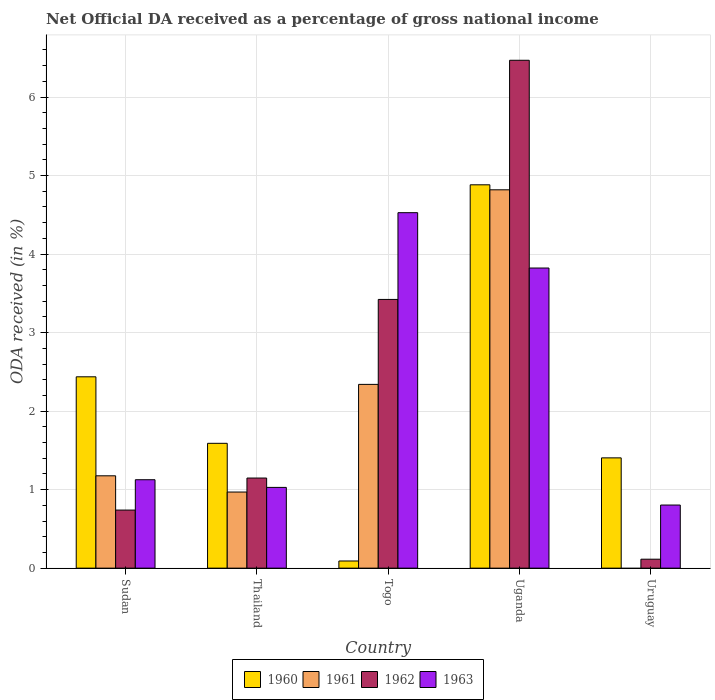How many groups of bars are there?
Offer a terse response. 5. Are the number of bars per tick equal to the number of legend labels?
Keep it short and to the point. No. Are the number of bars on each tick of the X-axis equal?
Your response must be concise. No. How many bars are there on the 4th tick from the left?
Your answer should be compact. 4. What is the label of the 1st group of bars from the left?
Keep it short and to the point. Sudan. What is the net official DA received in 1961 in Thailand?
Offer a terse response. 0.97. Across all countries, what is the maximum net official DA received in 1961?
Your response must be concise. 4.82. Across all countries, what is the minimum net official DA received in 1962?
Ensure brevity in your answer.  0.11. In which country was the net official DA received in 1961 maximum?
Provide a succinct answer. Uganda. What is the total net official DA received in 1961 in the graph?
Make the answer very short. 9.3. What is the difference between the net official DA received in 1960 in Sudan and that in Thailand?
Provide a short and direct response. 0.85. What is the difference between the net official DA received in 1962 in Sudan and the net official DA received in 1963 in Uruguay?
Ensure brevity in your answer.  -0.06. What is the average net official DA received in 1962 per country?
Your response must be concise. 2.38. What is the difference between the net official DA received of/in 1961 and net official DA received of/in 1963 in Uganda?
Make the answer very short. 1. What is the ratio of the net official DA received in 1961 in Sudan to that in Uganda?
Make the answer very short. 0.24. What is the difference between the highest and the second highest net official DA received in 1963?
Your answer should be compact. -2.7. What is the difference between the highest and the lowest net official DA received in 1960?
Give a very brief answer. 4.79. In how many countries, is the net official DA received in 1961 greater than the average net official DA received in 1961 taken over all countries?
Provide a succinct answer. 2. Is it the case that in every country, the sum of the net official DA received in 1963 and net official DA received in 1961 is greater than the sum of net official DA received in 1960 and net official DA received in 1962?
Give a very brief answer. No. Are all the bars in the graph horizontal?
Give a very brief answer. No. What is the difference between two consecutive major ticks on the Y-axis?
Make the answer very short. 1. Are the values on the major ticks of Y-axis written in scientific E-notation?
Give a very brief answer. No. Where does the legend appear in the graph?
Your response must be concise. Bottom center. What is the title of the graph?
Your answer should be compact. Net Official DA received as a percentage of gross national income. What is the label or title of the Y-axis?
Ensure brevity in your answer.  ODA received (in %). What is the ODA received (in %) in 1960 in Sudan?
Keep it short and to the point. 2.44. What is the ODA received (in %) of 1961 in Sudan?
Your answer should be very brief. 1.18. What is the ODA received (in %) of 1962 in Sudan?
Offer a terse response. 0.74. What is the ODA received (in %) of 1963 in Sudan?
Provide a short and direct response. 1.13. What is the ODA received (in %) in 1960 in Thailand?
Ensure brevity in your answer.  1.59. What is the ODA received (in %) of 1961 in Thailand?
Offer a very short reply. 0.97. What is the ODA received (in %) in 1962 in Thailand?
Make the answer very short. 1.15. What is the ODA received (in %) of 1963 in Thailand?
Your answer should be compact. 1.03. What is the ODA received (in %) of 1960 in Togo?
Your response must be concise. 0.09. What is the ODA received (in %) in 1961 in Togo?
Keep it short and to the point. 2.34. What is the ODA received (in %) in 1962 in Togo?
Your answer should be very brief. 3.42. What is the ODA received (in %) in 1963 in Togo?
Ensure brevity in your answer.  4.53. What is the ODA received (in %) in 1960 in Uganda?
Keep it short and to the point. 4.88. What is the ODA received (in %) of 1961 in Uganda?
Offer a terse response. 4.82. What is the ODA received (in %) in 1962 in Uganda?
Offer a very short reply. 6.47. What is the ODA received (in %) in 1963 in Uganda?
Your answer should be compact. 3.82. What is the ODA received (in %) in 1960 in Uruguay?
Make the answer very short. 1.4. What is the ODA received (in %) in 1962 in Uruguay?
Give a very brief answer. 0.11. What is the ODA received (in %) of 1963 in Uruguay?
Your answer should be compact. 0.8. Across all countries, what is the maximum ODA received (in %) in 1960?
Keep it short and to the point. 4.88. Across all countries, what is the maximum ODA received (in %) of 1961?
Provide a short and direct response. 4.82. Across all countries, what is the maximum ODA received (in %) in 1962?
Provide a succinct answer. 6.47. Across all countries, what is the maximum ODA received (in %) of 1963?
Provide a short and direct response. 4.53. Across all countries, what is the minimum ODA received (in %) in 1960?
Make the answer very short. 0.09. Across all countries, what is the minimum ODA received (in %) in 1961?
Make the answer very short. 0. Across all countries, what is the minimum ODA received (in %) in 1962?
Provide a short and direct response. 0.11. Across all countries, what is the minimum ODA received (in %) of 1963?
Make the answer very short. 0.8. What is the total ODA received (in %) of 1960 in the graph?
Your answer should be compact. 10.41. What is the total ODA received (in %) in 1961 in the graph?
Provide a succinct answer. 9.3. What is the total ODA received (in %) of 1962 in the graph?
Your answer should be compact. 11.89. What is the total ODA received (in %) of 1963 in the graph?
Offer a very short reply. 11.31. What is the difference between the ODA received (in %) in 1960 in Sudan and that in Thailand?
Give a very brief answer. 0.85. What is the difference between the ODA received (in %) of 1961 in Sudan and that in Thailand?
Give a very brief answer. 0.21. What is the difference between the ODA received (in %) in 1962 in Sudan and that in Thailand?
Ensure brevity in your answer.  -0.41. What is the difference between the ODA received (in %) of 1963 in Sudan and that in Thailand?
Your answer should be very brief. 0.1. What is the difference between the ODA received (in %) in 1960 in Sudan and that in Togo?
Your response must be concise. 2.35. What is the difference between the ODA received (in %) in 1961 in Sudan and that in Togo?
Your answer should be compact. -1.16. What is the difference between the ODA received (in %) of 1962 in Sudan and that in Togo?
Give a very brief answer. -2.68. What is the difference between the ODA received (in %) of 1963 in Sudan and that in Togo?
Provide a short and direct response. -3.4. What is the difference between the ODA received (in %) of 1960 in Sudan and that in Uganda?
Offer a terse response. -2.45. What is the difference between the ODA received (in %) in 1961 in Sudan and that in Uganda?
Your answer should be very brief. -3.64. What is the difference between the ODA received (in %) in 1962 in Sudan and that in Uganda?
Your response must be concise. -5.73. What is the difference between the ODA received (in %) in 1963 in Sudan and that in Uganda?
Provide a succinct answer. -2.7. What is the difference between the ODA received (in %) of 1960 in Sudan and that in Uruguay?
Keep it short and to the point. 1.03. What is the difference between the ODA received (in %) of 1962 in Sudan and that in Uruguay?
Provide a succinct answer. 0.63. What is the difference between the ODA received (in %) of 1963 in Sudan and that in Uruguay?
Offer a terse response. 0.32. What is the difference between the ODA received (in %) in 1960 in Thailand and that in Togo?
Make the answer very short. 1.5. What is the difference between the ODA received (in %) of 1961 in Thailand and that in Togo?
Your response must be concise. -1.37. What is the difference between the ODA received (in %) of 1962 in Thailand and that in Togo?
Your answer should be very brief. -2.27. What is the difference between the ODA received (in %) in 1963 in Thailand and that in Togo?
Give a very brief answer. -3.5. What is the difference between the ODA received (in %) of 1960 in Thailand and that in Uganda?
Keep it short and to the point. -3.29. What is the difference between the ODA received (in %) in 1961 in Thailand and that in Uganda?
Your answer should be compact. -3.85. What is the difference between the ODA received (in %) of 1962 in Thailand and that in Uganda?
Give a very brief answer. -5.32. What is the difference between the ODA received (in %) of 1963 in Thailand and that in Uganda?
Keep it short and to the point. -2.79. What is the difference between the ODA received (in %) in 1960 in Thailand and that in Uruguay?
Keep it short and to the point. 0.19. What is the difference between the ODA received (in %) in 1962 in Thailand and that in Uruguay?
Provide a short and direct response. 1.03. What is the difference between the ODA received (in %) of 1963 in Thailand and that in Uruguay?
Your answer should be very brief. 0.22. What is the difference between the ODA received (in %) of 1960 in Togo and that in Uganda?
Your answer should be very brief. -4.79. What is the difference between the ODA received (in %) in 1961 in Togo and that in Uganda?
Give a very brief answer. -2.48. What is the difference between the ODA received (in %) of 1962 in Togo and that in Uganda?
Provide a short and direct response. -3.05. What is the difference between the ODA received (in %) of 1963 in Togo and that in Uganda?
Your answer should be very brief. 0.7. What is the difference between the ODA received (in %) in 1960 in Togo and that in Uruguay?
Ensure brevity in your answer.  -1.31. What is the difference between the ODA received (in %) of 1962 in Togo and that in Uruguay?
Give a very brief answer. 3.31. What is the difference between the ODA received (in %) in 1963 in Togo and that in Uruguay?
Your answer should be very brief. 3.72. What is the difference between the ODA received (in %) of 1960 in Uganda and that in Uruguay?
Offer a terse response. 3.48. What is the difference between the ODA received (in %) of 1962 in Uganda and that in Uruguay?
Your answer should be very brief. 6.35. What is the difference between the ODA received (in %) of 1963 in Uganda and that in Uruguay?
Your answer should be compact. 3.02. What is the difference between the ODA received (in %) in 1960 in Sudan and the ODA received (in %) in 1961 in Thailand?
Provide a short and direct response. 1.47. What is the difference between the ODA received (in %) in 1960 in Sudan and the ODA received (in %) in 1962 in Thailand?
Your answer should be very brief. 1.29. What is the difference between the ODA received (in %) of 1960 in Sudan and the ODA received (in %) of 1963 in Thailand?
Provide a succinct answer. 1.41. What is the difference between the ODA received (in %) in 1961 in Sudan and the ODA received (in %) in 1962 in Thailand?
Make the answer very short. 0.03. What is the difference between the ODA received (in %) of 1961 in Sudan and the ODA received (in %) of 1963 in Thailand?
Give a very brief answer. 0.15. What is the difference between the ODA received (in %) of 1962 in Sudan and the ODA received (in %) of 1963 in Thailand?
Provide a short and direct response. -0.29. What is the difference between the ODA received (in %) in 1960 in Sudan and the ODA received (in %) in 1961 in Togo?
Your response must be concise. 0.1. What is the difference between the ODA received (in %) of 1960 in Sudan and the ODA received (in %) of 1962 in Togo?
Make the answer very short. -0.99. What is the difference between the ODA received (in %) in 1960 in Sudan and the ODA received (in %) in 1963 in Togo?
Provide a succinct answer. -2.09. What is the difference between the ODA received (in %) in 1961 in Sudan and the ODA received (in %) in 1962 in Togo?
Your answer should be very brief. -2.25. What is the difference between the ODA received (in %) of 1961 in Sudan and the ODA received (in %) of 1963 in Togo?
Provide a succinct answer. -3.35. What is the difference between the ODA received (in %) of 1962 in Sudan and the ODA received (in %) of 1963 in Togo?
Offer a terse response. -3.79. What is the difference between the ODA received (in %) in 1960 in Sudan and the ODA received (in %) in 1961 in Uganda?
Offer a very short reply. -2.38. What is the difference between the ODA received (in %) in 1960 in Sudan and the ODA received (in %) in 1962 in Uganda?
Your answer should be very brief. -4.03. What is the difference between the ODA received (in %) of 1960 in Sudan and the ODA received (in %) of 1963 in Uganda?
Ensure brevity in your answer.  -1.39. What is the difference between the ODA received (in %) in 1961 in Sudan and the ODA received (in %) in 1962 in Uganda?
Offer a very short reply. -5.29. What is the difference between the ODA received (in %) of 1961 in Sudan and the ODA received (in %) of 1963 in Uganda?
Provide a short and direct response. -2.65. What is the difference between the ODA received (in %) in 1962 in Sudan and the ODA received (in %) in 1963 in Uganda?
Offer a very short reply. -3.08. What is the difference between the ODA received (in %) in 1960 in Sudan and the ODA received (in %) in 1962 in Uruguay?
Keep it short and to the point. 2.32. What is the difference between the ODA received (in %) of 1960 in Sudan and the ODA received (in %) of 1963 in Uruguay?
Offer a very short reply. 1.63. What is the difference between the ODA received (in %) in 1961 in Sudan and the ODA received (in %) in 1962 in Uruguay?
Ensure brevity in your answer.  1.06. What is the difference between the ODA received (in %) in 1961 in Sudan and the ODA received (in %) in 1963 in Uruguay?
Make the answer very short. 0.37. What is the difference between the ODA received (in %) in 1962 in Sudan and the ODA received (in %) in 1963 in Uruguay?
Offer a very short reply. -0.06. What is the difference between the ODA received (in %) in 1960 in Thailand and the ODA received (in %) in 1961 in Togo?
Provide a succinct answer. -0.75. What is the difference between the ODA received (in %) of 1960 in Thailand and the ODA received (in %) of 1962 in Togo?
Provide a short and direct response. -1.83. What is the difference between the ODA received (in %) in 1960 in Thailand and the ODA received (in %) in 1963 in Togo?
Give a very brief answer. -2.94. What is the difference between the ODA received (in %) in 1961 in Thailand and the ODA received (in %) in 1962 in Togo?
Offer a very short reply. -2.45. What is the difference between the ODA received (in %) in 1961 in Thailand and the ODA received (in %) in 1963 in Togo?
Make the answer very short. -3.56. What is the difference between the ODA received (in %) of 1962 in Thailand and the ODA received (in %) of 1963 in Togo?
Give a very brief answer. -3.38. What is the difference between the ODA received (in %) in 1960 in Thailand and the ODA received (in %) in 1961 in Uganda?
Your answer should be very brief. -3.23. What is the difference between the ODA received (in %) of 1960 in Thailand and the ODA received (in %) of 1962 in Uganda?
Your response must be concise. -4.88. What is the difference between the ODA received (in %) of 1960 in Thailand and the ODA received (in %) of 1963 in Uganda?
Your answer should be very brief. -2.23. What is the difference between the ODA received (in %) of 1961 in Thailand and the ODA received (in %) of 1962 in Uganda?
Your response must be concise. -5.5. What is the difference between the ODA received (in %) of 1961 in Thailand and the ODA received (in %) of 1963 in Uganda?
Keep it short and to the point. -2.85. What is the difference between the ODA received (in %) of 1962 in Thailand and the ODA received (in %) of 1963 in Uganda?
Your answer should be very brief. -2.67. What is the difference between the ODA received (in %) of 1960 in Thailand and the ODA received (in %) of 1962 in Uruguay?
Provide a short and direct response. 1.48. What is the difference between the ODA received (in %) in 1960 in Thailand and the ODA received (in %) in 1963 in Uruguay?
Keep it short and to the point. 0.79. What is the difference between the ODA received (in %) in 1961 in Thailand and the ODA received (in %) in 1962 in Uruguay?
Provide a short and direct response. 0.86. What is the difference between the ODA received (in %) of 1961 in Thailand and the ODA received (in %) of 1963 in Uruguay?
Your answer should be very brief. 0.17. What is the difference between the ODA received (in %) of 1962 in Thailand and the ODA received (in %) of 1963 in Uruguay?
Give a very brief answer. 0.34. What is the difference between the ODA received (in %) in 1960 in Togo and the ODA received (in %) in 1961 in Uganda?
Your response must be concise. -4.73. What is the difference between the ODA received (in %) in 1960 in Togo and the ODA received (in %) in 1962 in Uganda?
Give a very brief answer. -6.38. What is the difference between the ODA received (in %) of 1960 in Togo and the ODA received (in %) of 1963 in Uganda?
Offer a terse response. -3.73. What is the difference between the ODA received (in %) in 1961 in Togo and the ODA received (in %) in 1962 in Uganda?
Offer a terse response. -4.13. What is the difference between the ODA received (in %) in 1961 in Togo and the ODA received (in %) in 1963 in Uganda?
Your response must be concise. -1.48. What is the difference between the ODA received (in %) in 1962 in Togo and the ODA received (in %) in 1963 in Uganda?
Your answer should be compact. -0.4. What is the difference between the ODA received (in %) of 1960 in Togo and the ODA received (in %) of 1962 in Uruguay?
Offer a terse response. -0.02. What is the difference between the ODA received (in %) in 1960 in Togo and the ODA received (in %) in 1963 in Uruguay?
Provide a short and direct response. -0.71. What is the difference between the ODA received (in %) of 1961 in Togo and the ODA received (in %) of 1962 in Uruguay?
Keep it short and to the point. 2.23. What is the difference between the ODA received (in %) of 1961 in Togo and the ODA received (in %) of 1963 in Uruguay?
Ensure brevity in your answer.  1.54. What is the difference between the ODA received (in %) of 1962 in Togo and the ODA received (in %) of 1963 in Uruguay?
Your response must be concise. 2.62. What is the difference between the ODA received (in %) of 1960 in Uganda and the ODA received (in %) of 1962 in Uruguay?
Give a very brief answer. 4.77. What is the difference between the ODA received (in %) of 1960 in Uganda and the ODA received (in %) of 1963 in Uruguay?
Your answer should be compact. 4.08. What is the difference between the ODA received (in %) of 1961 in Uganda and the ODA received (in %) of 1962 in Uruguay?
Make the answer very short. 4.7. What is the difference between the ODA received (in %) in 1961 in Uganda and the ODA received (in %) in 1963 in Uruguay?
Provide a short and direct response. 4.01. What is the difference between the ODA received (in %) of 1962 in Uganda and the ODA received (in %) of 1963 in Uruguay?
Give a very brief answer. 5.66. What is the average ODA received (in %) of 1960 per country?
Ensure brevity in your answer.  2.08. What is the average ODA received (in %) in 1961 per country?
Your answer should be very brief. 1.86. What is the average ODA received (in %) in 1962 per country?
Make the answer very short. 2.38. What is the average ODA received (in %) in 1963 per country?
Provide a short and direct response. 2.26. What is the difference between the ODA received (in %) in 1960 and ODA received (in %) in 1961 in Sudan?
Your answer should be compact. 1.26. What is the difference between the ODA received (in %) in 1960 and ODA received (in %) in 1962 in Sudan?
Ensure brevity in your answer.  1.7. What is the difference between the ODA received (in %) of 1960 and ODA received (in %) of 1963 in Sudan?
Your answer should be compact. 1.31. What is the difference between the ODA received (in %) of 1961 and ODA received (in %) of 1962 in Sudan?
Your answer should be compact. 0.44. What is the difference between the ODA received (in %) in 1961 and ODA received (in %) in 1963 in Sudan?
Make the answer very short. 0.05. What is the difference between the ODA received (in %) in 1962 and ODA received (in %) in 1963 in Sudan?
Keep it short and to the point. -0.39. What is the difference between the ODA received (in %) of 1960 and ODA received (in %) of 1961 in Thailand?
Give a very brief answer. 0.62. What is the difference between the ODA received (in %) in 1960 and ODA received (in %) in 1962 in Thailand?
Ensure brevity in your answer.  0.44. What is the difference between the ODA received (in %) in 1960 and ODA received (in %) in 1963 in Thailand?
Your answer should be compact. 0.56. What is the difference between the ODA received (in %) of 1961 and ODA received (in %) of 1962 in Thailand?
Your answer should be compact. -0.18. What is the difference between the ODA received (in %) of 1961 and ODA received (in %) of 1963 in Thailand?
Ensure brevity in your answer.  -0.06. What is the difference between the ODA received (in %) in 1962 and ODA received (in %) in 1963 in Thailand?
Your answer should be very brief. 0.12. What is the difference between the ODA received (in %) in 1960 and ODA received (in %) in 1961 in Togo?
Provide a short and direct response. -2.25. What is the difference between the ODA received (in %) of 1960 and ODA received (in %) of 1962 in Togo?
Give a very brief answer. -3.33. What is the difference between the ODA received (in %) in 1960 and ODA received (in %) in 1963 in Togo?
Your response must be concise. -4.44. What is the difference between the ODA received (in %) of 1961 and ODA received (in %) of 1962 in Togo?
Ensure brevity in your answer.  -1.08. What is the difference between the ODA received (in %) of 1961 and ODA received (in %) of 1963 in Togo?
Your answer should be compact. -2.19. What is the difference between the ODA received (in %) of 1962 and ODA received (in %) of 1963 in Togo?
Keep it short and to the point. -1.1. What is the difference between the ODA received (in %) of 1960 and ODA received (in %) of 1961 in Uganda?
Your answer should be compact. 0.06. What is the difference between the ODA received (in %) of 1960 and ODA received (in %) of 1962 in Uganda?
Offer a very short reply. -1.59. What is the difference between the ODA received (in %) in 1960 and ODA received (in %) in 1963 in Uganda?
Offer a very short reply. 1.06. What is the difference between the ODA received (in %) of 1961 and ODA received (in %) of 1962 in Uganda?
Your answer should be compact. -1.65. What is the difference between the ODA received (in %) of 1962 and ODA received (in %) of 1963 in Uganda?
Keep it short and to the point. 2.65. What is the difference between the ODA received (in %) in 1960 and ODA received (in %) in 1962 in Uruguay?
Keep it short and to the point. 1.29. What is the difference between the ODA received (in %) of 1960 and ODA received (in %) of 1963 in Uruguay?
Provide a short and direct response. 0.6. What is the difference between the ODA received (in %) of 1962 and ODA received (in %) of 1963 in Uruguay?
Offer a terse response. -0.69. What is the ratio of the ODA received (in %) of 1960 in Sudan to that in Thailand?
Give a very brief answer. 1.53. What is the ratio of the ODA received (in %) of 1961 in Sudan to that in Thailand?
Provide a short and direct response. 1.21. What is the ratio of the ODA received (in %) of 1962 in Sudan to that in Thailand?
Your answer should be compact. 0.64. What is the ratio of the ODA received (in %) in 1963 in Sudan to that in Thailand?
Ensure brevity in your answer.  1.1. What is the ratio of the ODA received (in %) of 1960 in Sudan to that in Togo?
Ensure brevity in your answer.  26.73. What is the ratio of the ODA received (in %) in 1961 in Sudan to that in Togo?
Offer a very short reply. 0.5. What is the ratio of the ODA received (in %) in 1962 in Sudan to that in Togo?
Your response must be concise. 0.22. What is the ratio of the ODA received (in %) in 1963 in Sudan to that in Togo?
Offer a terse response. 0.25. What is the ratio of the ODA received (in %) of 1960 in Sudan to that in Uganda?
Ensure brevity in your answer.  0.5. What is the ratio of the ODA received (in %) in 1961 in Sudan to that in Uganda?
Offer a very short reply. 0.24. What is the ratio of the ODA received (in %) of 1962 in Sudan to that in Uganda?
Your answer should be very brief. 0.11. What is the ratio of the ODA received (in %) in 1963 in Sudan to that in Uganda?
Keep it short and to the point. 0.29. What is the ratio of the ODA received (in %) of 1960 in Sudan to that in Uruguay?
Provide a succinct answer. 1.73. What is the ratio of the ODA received (in %) of 1962 in Sudan to that in Uruguay?
Your response must be concise. 6.49. What is the ratio of the ODA received (in %) in 1963 in Sudan to that in Uruguay?
Ensure brevity in your answer.  1.4. What is the ratio of the ODA received (in %) in 1960 in Thailand to that in Togo?
Provide a short and direct response. 17.44. What is the ratio of the ODA received (in %) in 1961 in Thailand to that in Togo?
Give a very brief answer. 0.41. What is the ratio of the ODA received (in %) in 1962 in Thailand to that in Togo?
Your answer should be very brief. 0.34. What is the ratio of the ODA received (in %) of 1963 in Thailand to that in Togo?
Provide a succinct answer. 0.23. What is the ratio of the ODA received (in %) of 1960 in Thailand to that in Uganda?
Your response must be concise. 0.33. What is the ratio of the ODA received (in %) of 1961 in Thailand to that in Uganda?
Your response must be concise. 0.2. What is the ratio of the ODA received (in %) in 1962 in Thailand to that in Uganda?
Offer a terse response. 0.18. What is the ratio of the ODA received (in %) of 1963 in Thailand to that in Uganda?
Offer a very short reply. 0.27. What is the ratio of the ODA received (in %) in 1960 in Thailand to that in Uruguay?
Offer a terse response. 1.13. What is the ratio of the ODA received (in %) in 1962 in Thailand to that in Uruguay?
Your answer should be very brief. 10.06. What is the ratio of the ODA received (in %) in 1963 in Thailand to that in Uruguay?
Keep it short and to the point. 1.28. What is the ratio of the ODA received (in %) of 1960 in Togo to that in Uganda?
Offer a very short reply. 0.02. What is the ratio of the ODA received (in %) in 1961 in Togo to that in Uganda?
Ensure brevity in your answer.  0.49. What is the ratio of the ODA received (in %) in 1962 in Togo to that in Uganda?
Keep it short and to the point. 0.53. What is the ratio of the ODA received (in %) of 1963 in Togo to that in Uganda?
Make the answer very short. 1.18. What is the ratio of the ODA received (in %) in 1960 in Togo to that in Uruguay?
Give a very brief answer. 0.06. What is the ratio of the ODA received (in %) in 1962 in Togo to that in Uruguay?
Your response must be concise. 30.01. What is the ratio of the ODA received (in %) of 1963 in Togo to that in Uruguay?
Offer a very short reply. 5.63. What is the ratio of the ODA received (in %) in 1960 in Uganda to that in Uruguay?
Give a very brief answer. 3.48. What is the ratio of the ODA received (in %) in 1962 in Uganda to that in Uruguay?
Ensure brevity in your answer.  56.73. What is the ratio of the ODA received (in %) of 1963 in Uganda to that in Uruguay?
Give a very brief answer. 4.76. What is the difference between the highest and the second highest ODA received (in %) of 1960?
Offer a terse response. 2.45. What is the difference between the highest and the second highest ODA received (in %) in 1961?
Offer a terse response. 2.48. What is the difference between the highest and the second highest ODA received (in %) of 1962?
Give a very brief answer. 3.05. What is the difference between the highest and the second highest ODA received (in %) in 1963?
Keep it short and to the point. 0.7. What is the difference between the highest and the lowest ODA received (in %) in 1960?
Keep it short and to the point. 4.79. What is the difference between the highest and the lowest ODA received (in %) of 1961?
Make the answer very short. 4.82. What is the difference between the highest and the lowest ODA received (in %) of 1962?
Offer a terse response. 6.35. What is the difference between the highest and the lowest ODA received (in %) of 1963?
Ensure brevity in your answer.  3.72. 